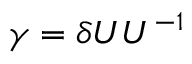<formula> <loc_0><loc_0><loc_500><loc_500>\gamma = \delta { U } U ^ { - 1 }</formula> 